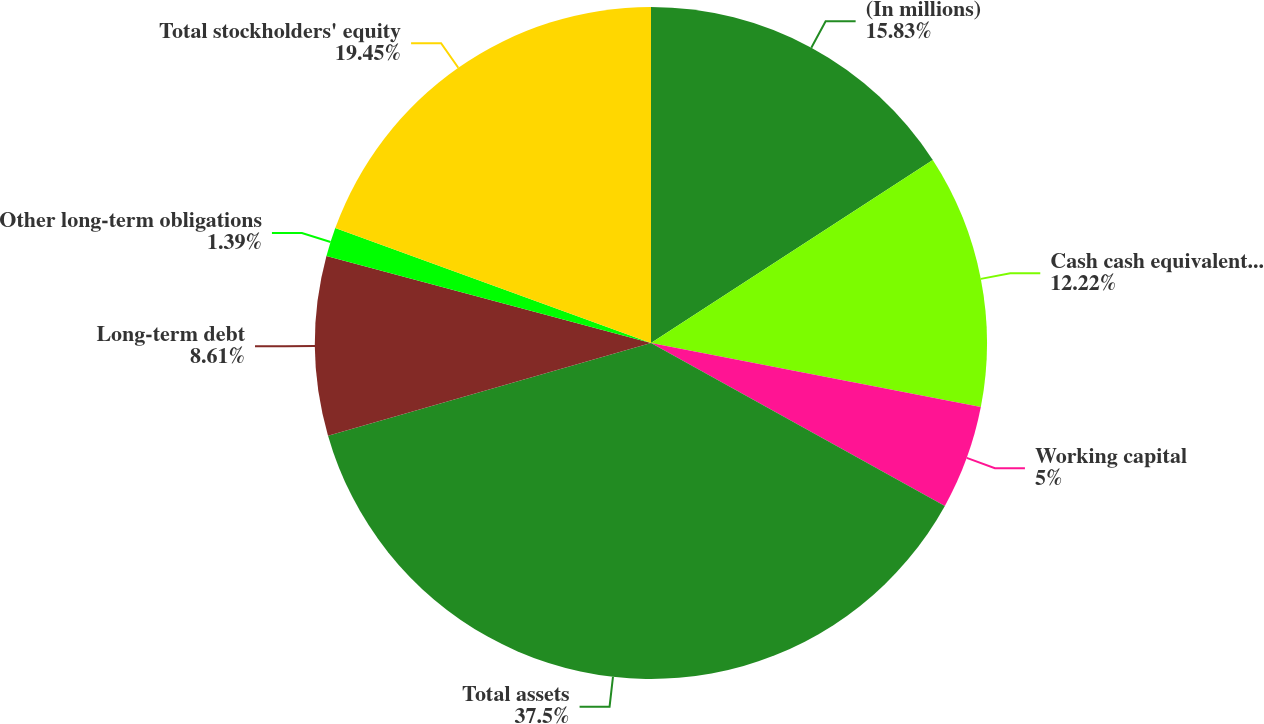Convert chart to OTSL. <chart><loc_0><loc_0><loc_500><loc_500><pie_chart><fcel>(In millions)<fcel>Cash cash equivalents and<fcel>Working capital<fcel>Total assets<fcel>Long-term debt<fcel>Other long-term obligations<fcel>Total stockholders' equity<nl><fcel>15.83%<fcel>12.22%<fcel>5.0%<fcel>37.49%<fcel>8.61%<fcel>1.39%<fcel>19.44%<nl></chart> 